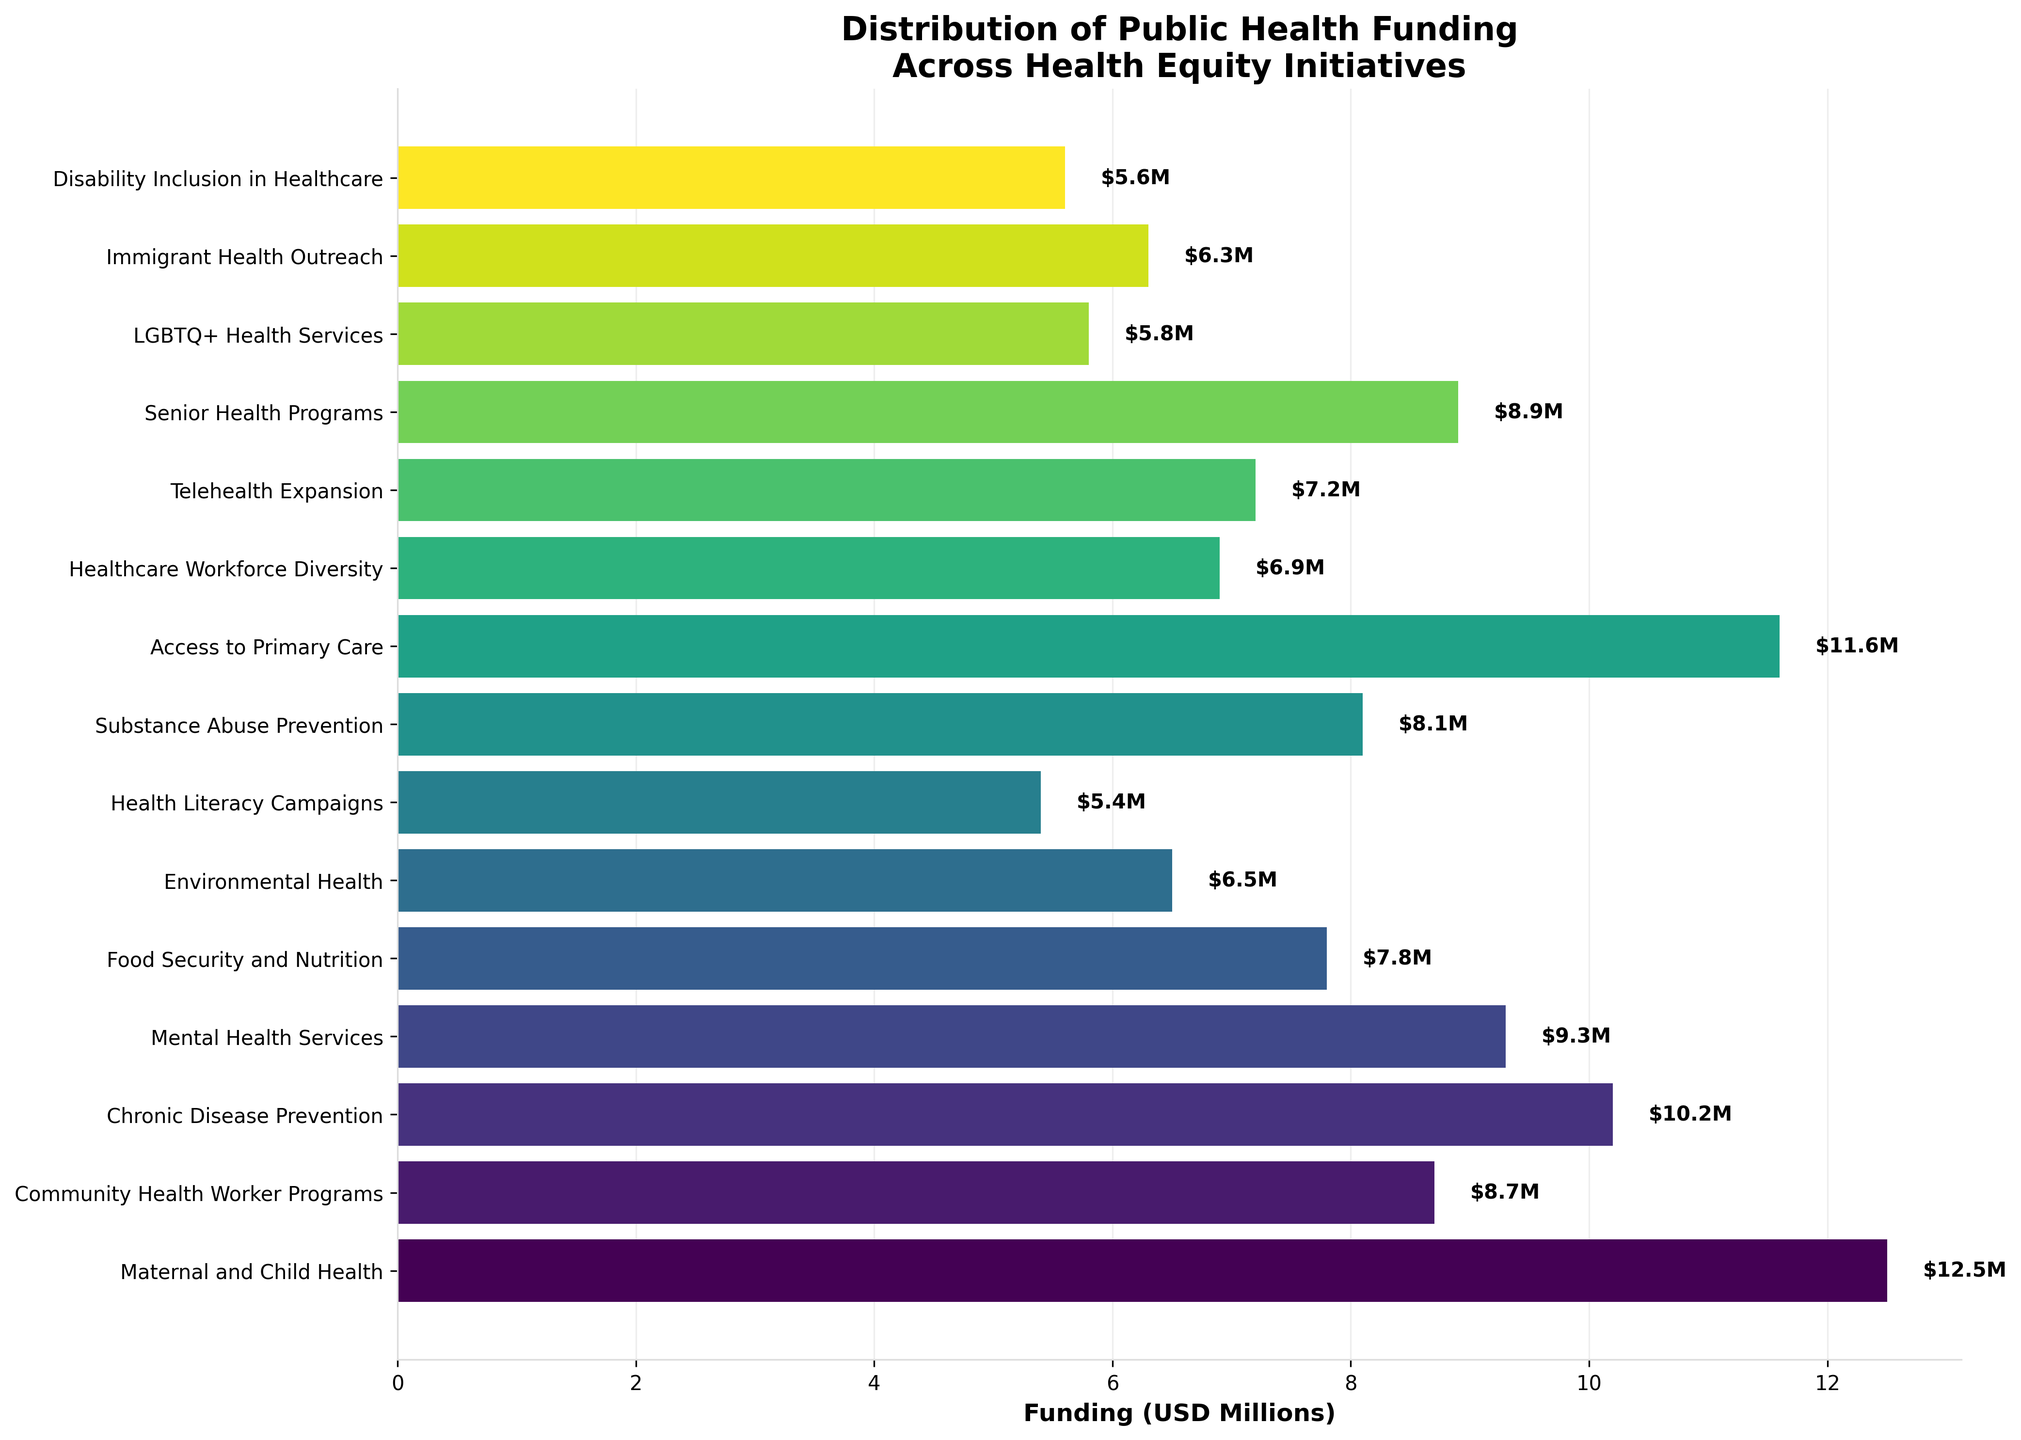Which initiative received the highest funding? The figure displays various funding amounts for different initiatives. The longest bar corresponds to the highest funding, which is labeled "Maternal and Child Health" with $12.5M.
Answer: Maternal and Child Health Which initiative has the lowest funding? The shortest bar, representing the lowest funding amount, corresponds to "Health Literacy Campaigns," which received $5.4M.
Answer: Health Literacy Campaigns What is the total funding allocated to "Access to Primary Care" and "Community Health Worker Programs"? "Access to Primary Care" received $11.6M, and "Community Health Worker Programs" received $8.7M. Adding these amounts gives $11.6M + $8.7M = $20.3M.
Answer: $20.3M How much more funding does "Maternal and Child Health" have than "Mental Health Services"? "Maternal and Child Health" received $12.5M, and "Mental Health Services" received $9.3M. The difference is $12.5M - $9.3M = $3.2M.
Answer: $3.2M Which initiative received the second-highest funding? The second-longest bar corresponds to "Access to Primary Care," which received $11.6M.
Answer: Access to Primary Care What is the average funding of "Telehealth Expansion," "Senior Health Programs," and "LGBTQ+ Health Services"? The funding amounts are $7.2M, $8.9M, and $5.8M respectively. Adding these amounts gives $7.2M + $8.9M + $5.8M = $21.9M. Dividing by 3 gives $21.9M / 3 = $7.3M.
Answer: $7.3M Which initiative received more funding: "Environmental Health" or "Food Security and Nutrition"? "Food Security and Nutrition" received $7.8M, and "Environmental Health" received $6.5M. Since $7.8M is greater than $6.5M, "Food Security and Nutrition" received more funding.
Answer: Food Security and Nutrition What is the combined funding for "Substance Abuse Prevention" and "Healthcare Workforce Diversity"? "Substance Abuse Prevention" received $8.1M, and "Healthcare Workforce Diversity" received $6.9M. Adding these gives $8.1M + $6.9M = $15M.
Answer: $15M Of the initiatives listed, which one has its funding amount closest to $7M? The initiative with funding closest to $7M is "Telehealth Expansion," which received $7.2M.
Answer: Telehealth Expansion By how much does the funding for "Chronic Disease Prevention" differ from the average funding of all initiatives? Sum all funding amounts: $12.5M + $8.7M + $10.2M + $9.3M + $7.8M + $6.5M + $5.4M + $8.1M + $11.6M + $6.9M + $7.2M + $8.9M + $5.8M + $6.3M + $5.6M = $111.8M. Dividing by 15 initiatives gives $111.8M / 15 ≈ $7.45M. Difference from $10.2M is $10.2M - $7.45M = $2.75M.
Answer: $2.75M 